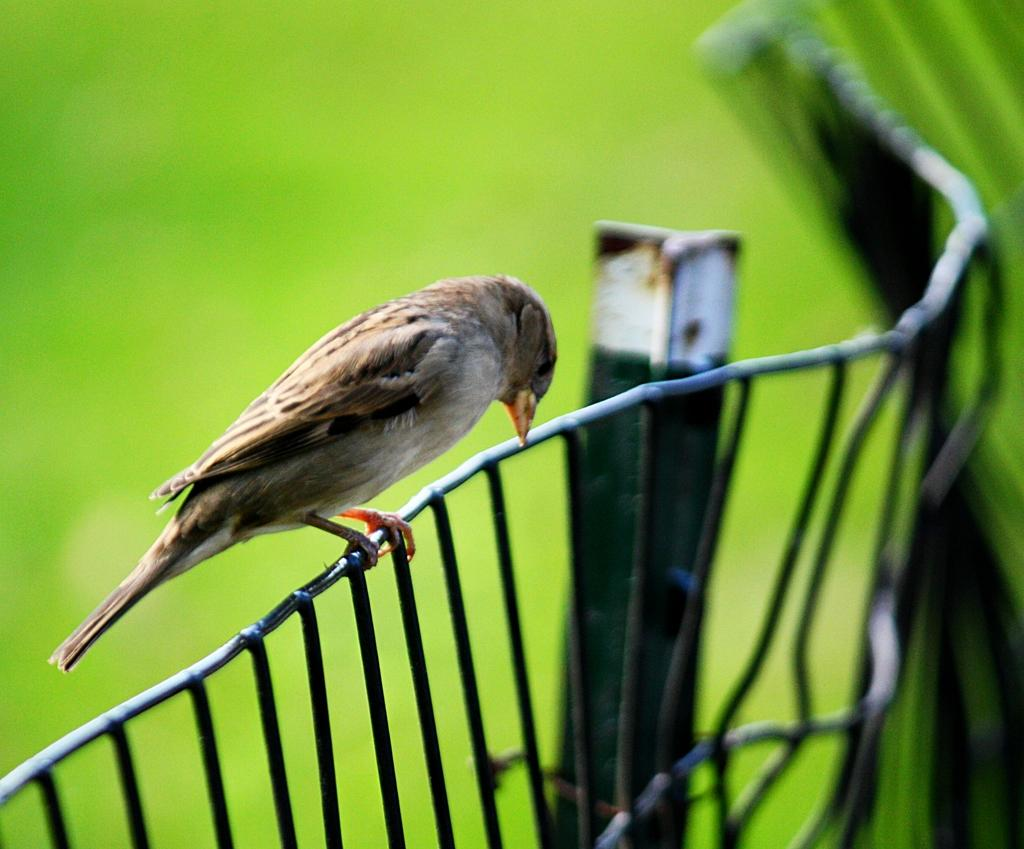What type of animal can be seen in the image? There is a bird in the image. Where is the bird located? The bird is on a fencing in the image. What other object is present in the image? There is a metal rod in the image. Can you describe the background of the image? The background of the image is blurred. What type of popcorn is being served for dinner in the image? There is no popcorn or dinner present in the image; it features a bird on a fencing and a metal rod. How is the knot tied on the bird's leg in the image? There is no knot or bird's leg visible in the image; it only shows a bird on a fencing and a metal rod. 